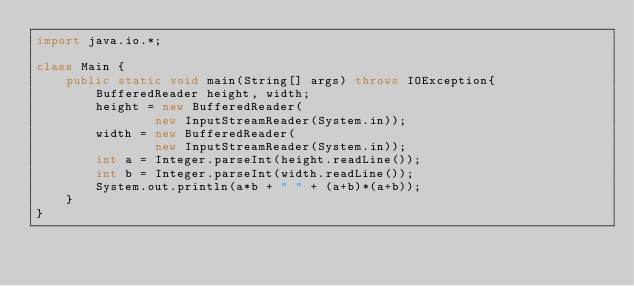Convert code to text. <code><loc_0><loc_0><loc_500><loc_500><_Java_>import java.io.*;

class Main {
    public static void main(String[] args) throws IOException{
        BufferedReader height, width;
        height = new BufferedReader(
                new InputStreamReader(System.in));
        width = new BufferedReader(
        		new InputStreamReader(System.in));
        int a = Integer.parseInt(height.readLine());
        int b = Integer.parseInt(width.readLine());
        System.out.println(a*b + " " + (a+b)*(a+b));
    }
}</code> 